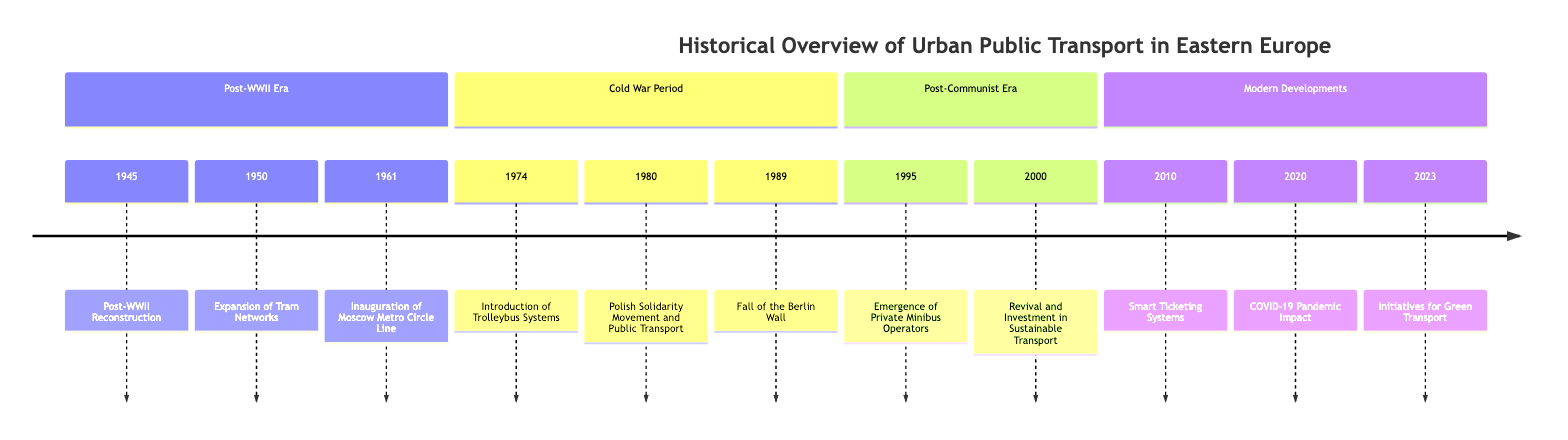What event marked the beginning of public transport reconstruction after WWII? The diagram shows that the first event listed in 1945 refers to "Post-WWII Reconstruction". This indicates that rebuilding efforts in urban public transport systems began after World War II.
Answer: Post-WWII Reconstruction Which city inaugurated the Circle Line of its metro system in 1961? The timeline specifically mentions in the year 1961, Moscow inaugurated its Metro Circle Line, signifying a significant accomplishment in urban transport in that city.
Answer: Moscow What type of public transport system was introduced in Kyiv and Bucharest in 1974? According to the timeline, the 1974 event highlights the "Introduction of Trolleybus Systems", indicating that these cities adopted this mode of transport at that time.
Answer: Trolleybus Systems How many key periods are outlined in this timeline? The timeline is divided into four distinct sections: Post-WWII Era, Cold War Period, Post-Communist Era, and Modern Developments. This division indicates there are four key periods listed.
Answer: 4 In what year did the fall of the Berlin Wall occur? The timeline clearly indicates that the fall of the Berlin Wall happened in the year 1989, capturing a significant historical moment that affected public transport systems.
Answer: 1989 What innovation was introduced in public transport in 2010? The line detailing the year 2010 mentions "Smart Ticketing Systems", identifying this innovation as a significant change in the public transport system during that year.
Answer: Smart Ticketing Systems Which cities experienced the emergence of private minibus operators in 1995? The timeline notes that in 1995, the cities such as Sofia and Bucharest saw the rise of private minibus operators, supplementing existing public transport.
Answer: Sofia and Bucharest What was a major impact of the COVID-19 pandemic in relation to public transport systems as noted in 2020? The timeline indicates that due to the COVID-19 pandemic, cities had to re-evaluate their public transport services and enforce health measures in 2020. This reflects a significant operational impact due to the pandemic.
Answer: Re-evaluate services and enforce health measures What recent initiatives began in 2023 concerning urban transport? According to the timeline, the year 2023 marks the "Initiatives for Green Transport," highlighting the introduction of more sustainable options, such as electric buses and cycling infrastructure.
Answer: Initiatives for Green Transport 